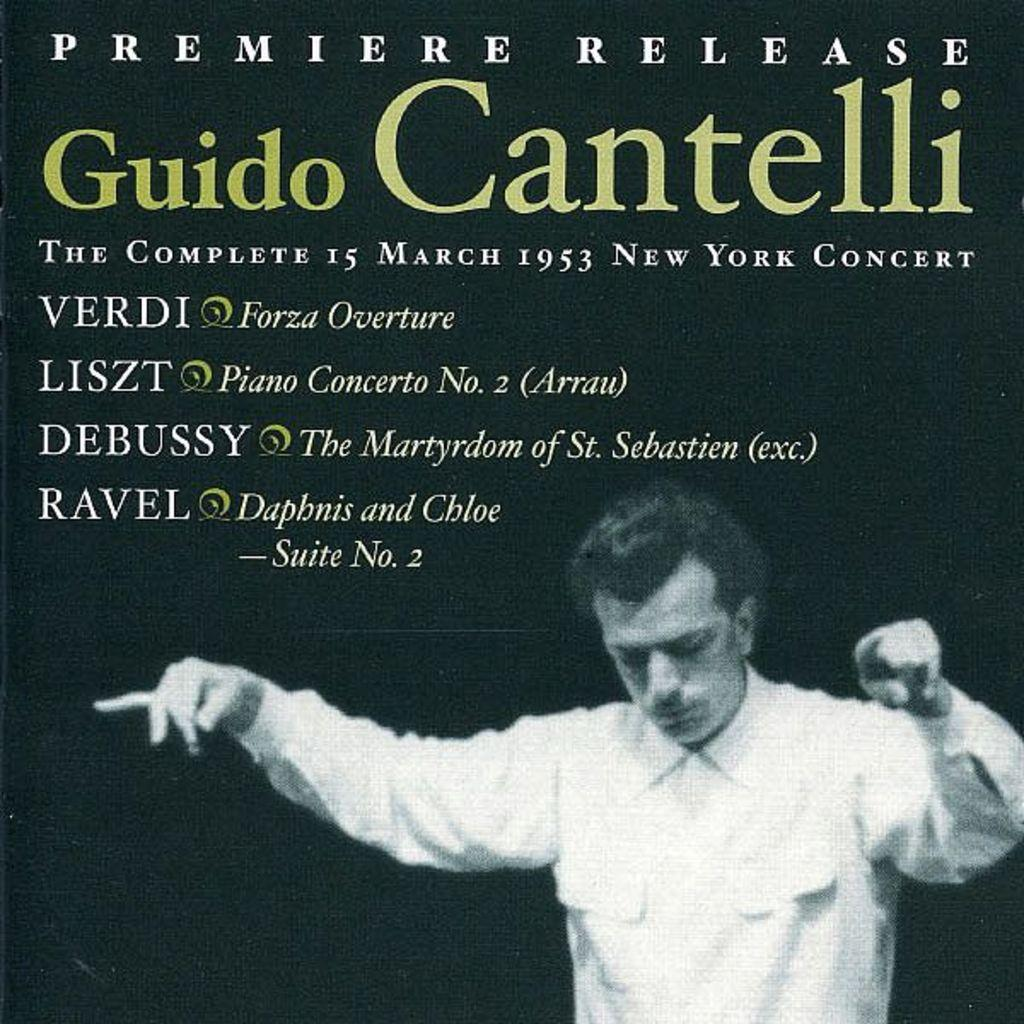What type of visual is the image? The image is a poster. What is the main subject of the poster? There is a man standing at the bottom of the poster. What is the man wearing in the poster? The man is wearing a shirt. What else can be seen in the poster besides the man? There is text visible in the background of the poster. Can you see any engines in the poster? There are no engines visible in the poster. What place is depicted in the poster? The poster does not depict a specific place; it features a man standing at the bottom and text in the background. 